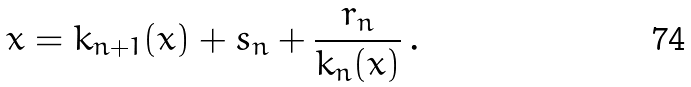Convert formula to latex. <formula><loc_0><loc_0><loc_500><loc_500>x = k _ { n + 1 } ( x ) + s _ { n } + \frac { r _ { n } } { k _ { n } ( x ) } \, .</formula> 